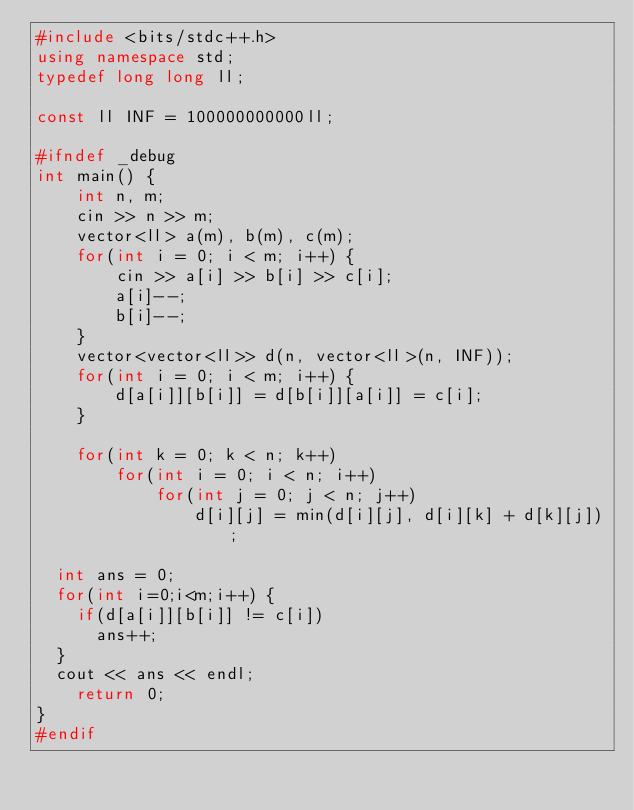<code> <loc_0><loc_0><loc_500><loc_500><_C++_>#include <bits/stdc++.h>
using namespace std;
typedef long long ll;

const ll INF = 100000000000ll;

#ifndef _debug
int main() {
    int n, m;
    cin >> n >> m;
    vector<ll> a(m), b(m), c(m);
    for(int i = 0; i < m; i++) {
        cin >> a[i] >> b[i] >> c[i];
        a[i]--;
        b[i]--;
    }
    vector<vector<ll>> d(n, vector<ll>(n, INF));
    for(int i = 0; i < m; i++) {
        d[a[i]][b[i]] = d[b[i]][a[i]] = c[i];
    }

    for(int k = 0; k < n; k++)
        for(int i = 0; i < n; i++)
            for(int j = 0; j < n; j++)
                d[i][j] = min(d[i][j], d[i][k] + d[k][j]);

	int ans = 0;
	for(int i=0;i<m;i++) {
		if(d[a[i]][b[i]] != c[i])
			ans++;
	}
	cout << ans << endl;
    return 0;
}
#endif</code> 